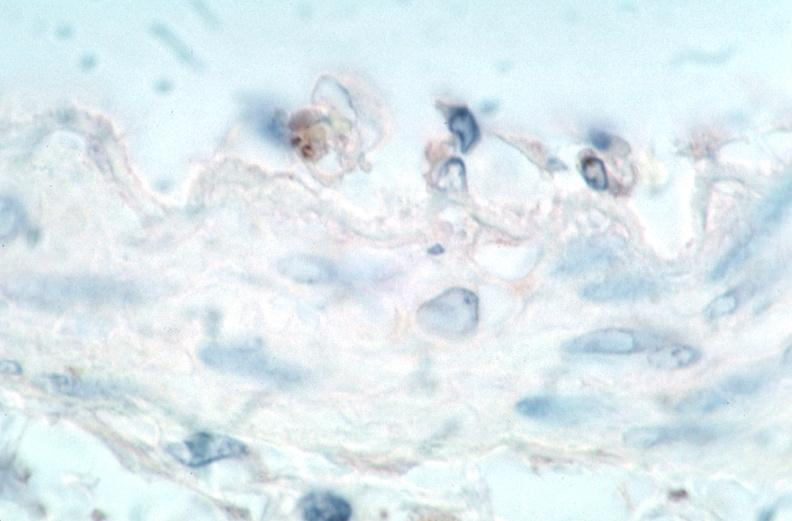s slide spotted fever, immunoperoxidase staining vessels for rickettsia rickettsii?
Answer the question using a single word or phrase. No 